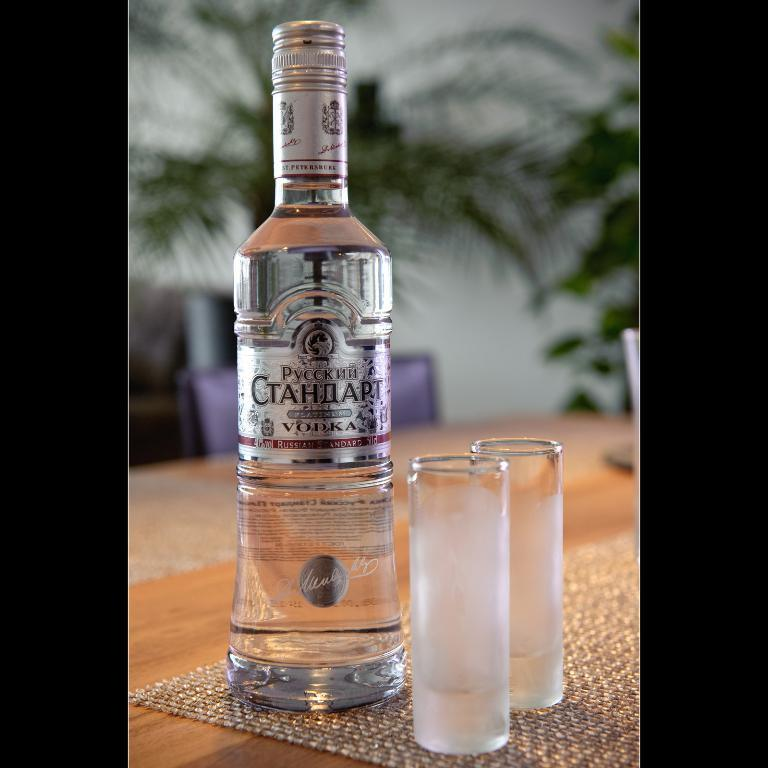<image>
Create a compact narrative representing the image presented. A bottle of vodka from Russia is on a table with two shot glasses. 